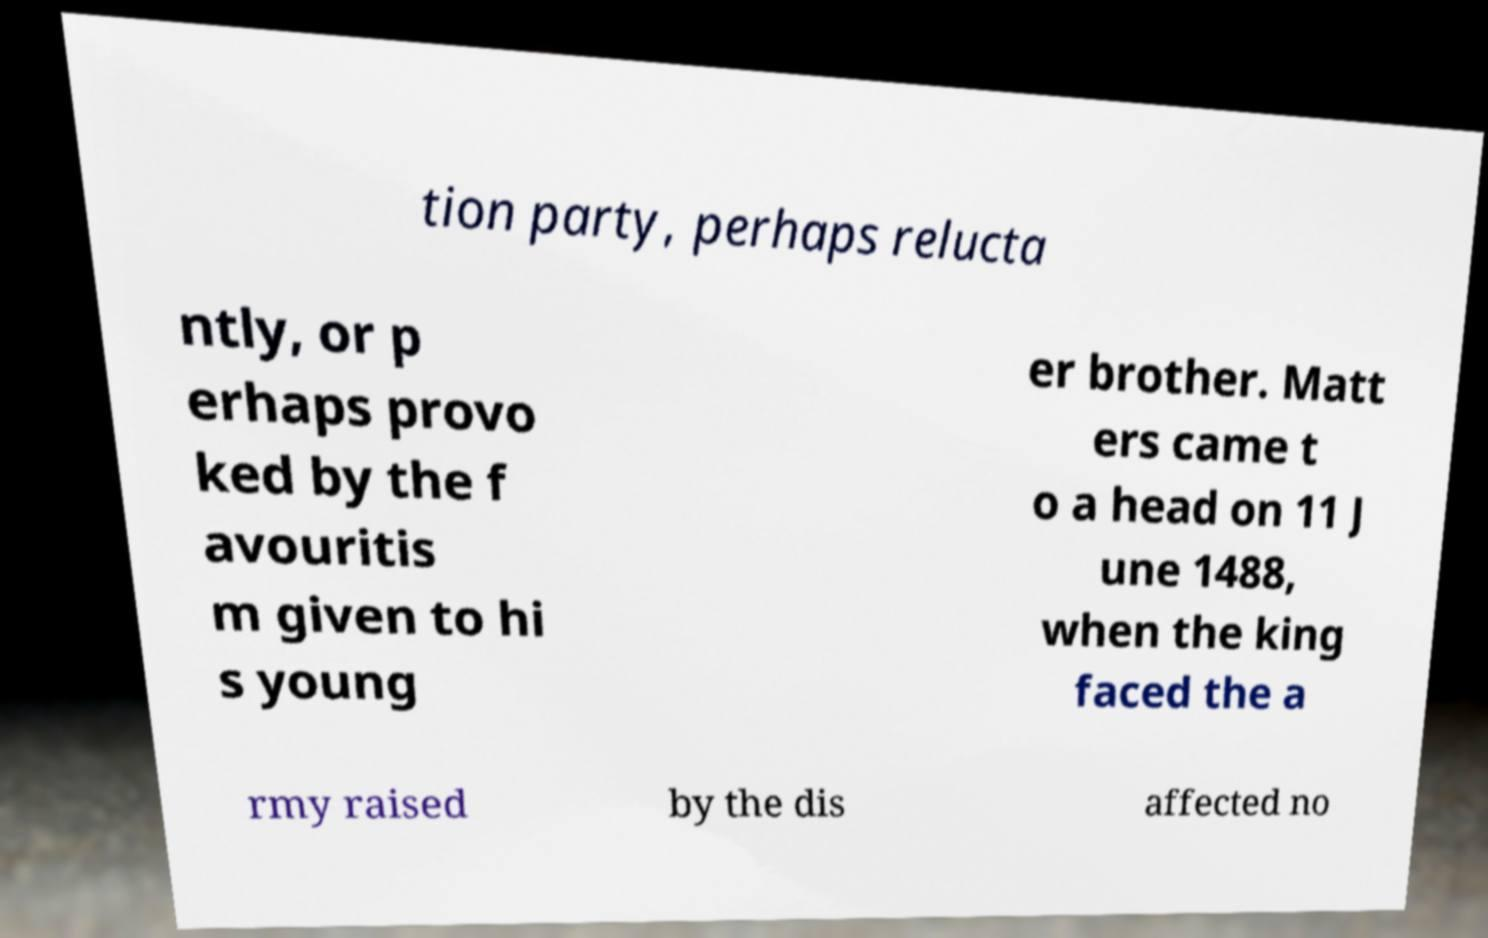Could you assist in decoding the text presented in this image and type it out clearly? tion party, perhaps relucta ntly, or p erhaps provo ked by the f avouritis m given to hi s young er brother. Matt ers came t o a head on 11 J une 1488, when the king faced the a rmy raised by the dis affected no 